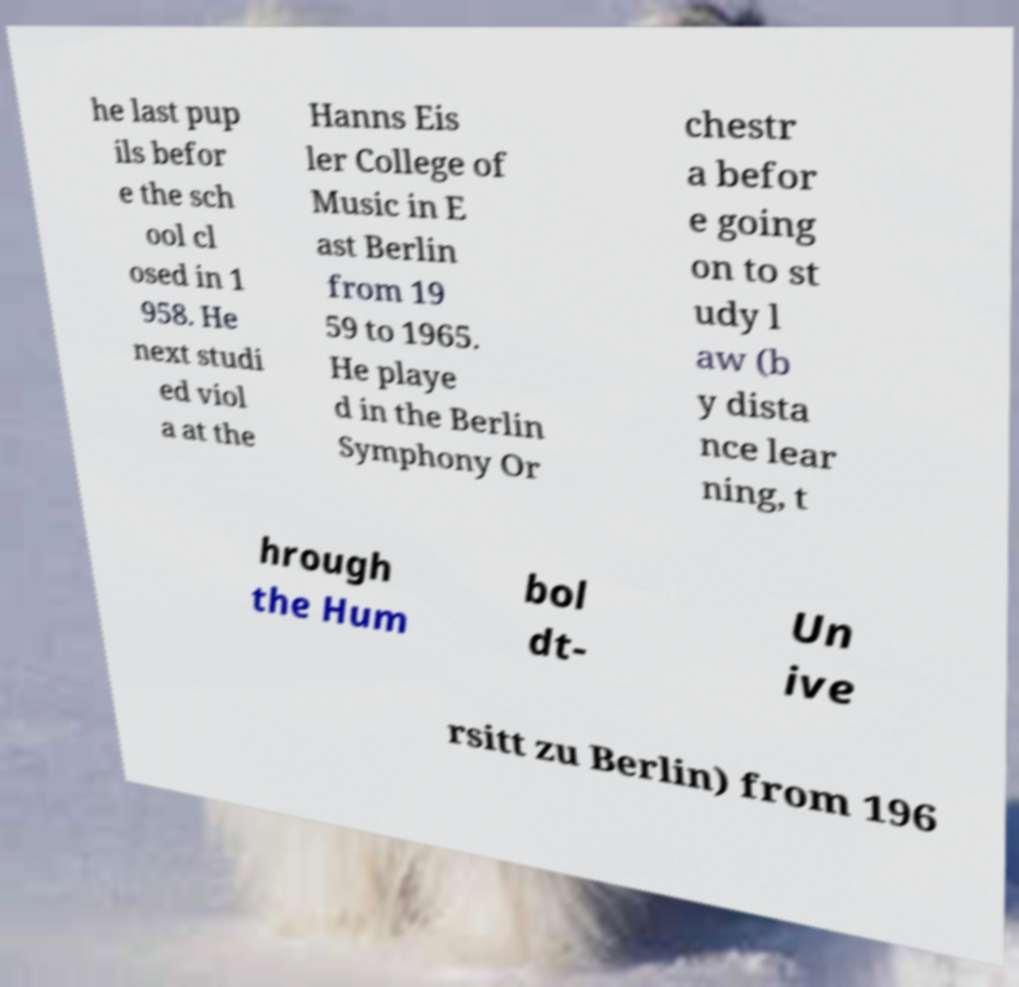For documentation purposes, I need the text within this image transcribed. Could you provide that? he last pup ils befor e the sch ool cl osed in 1 958. He next studi ed viol a at the Hanns Eis ler College of Music in E ast Berlin from 19 59 to 1965. He playe d in the Berlin Symphony Or chestr a befor e going on to st udy l aw (b y dista nce lear ning, t hrough the Hum bol dt- Un ive rsitt zu Berlin) from 196 